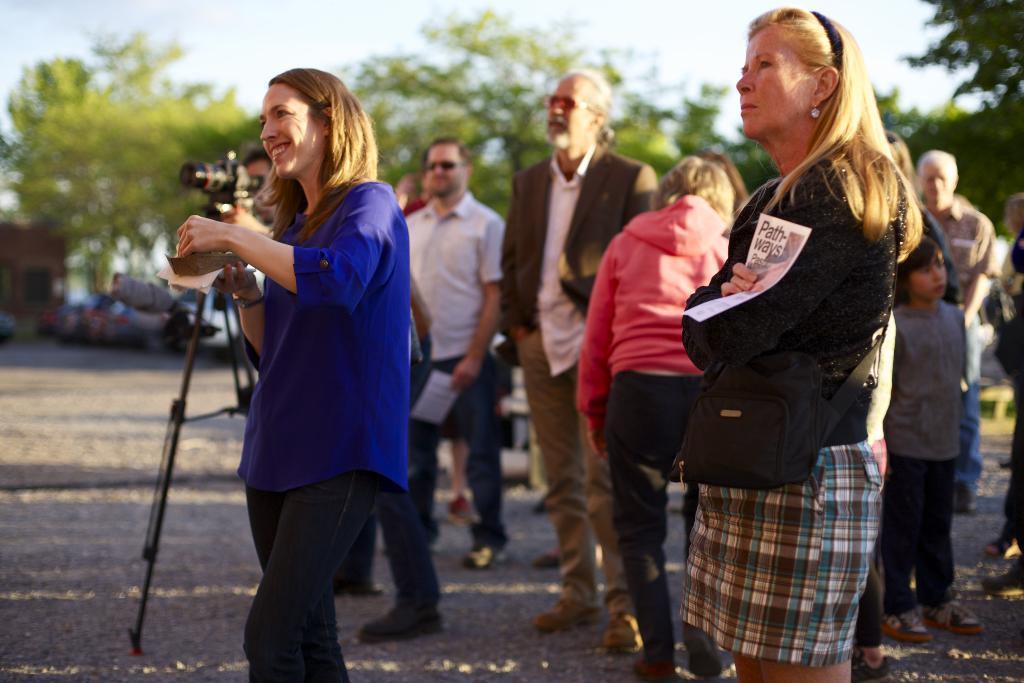Can you describe this image briefly? In this image we can see one building on the left side of the image, some people standing on the road, some people walking, some people holding objects, one object near the camera, one camera with stand on the road, one green object on the right side of the image, some cars near the building, some trees and grass on the ground. At the top there is the sky and the background is blurred. 